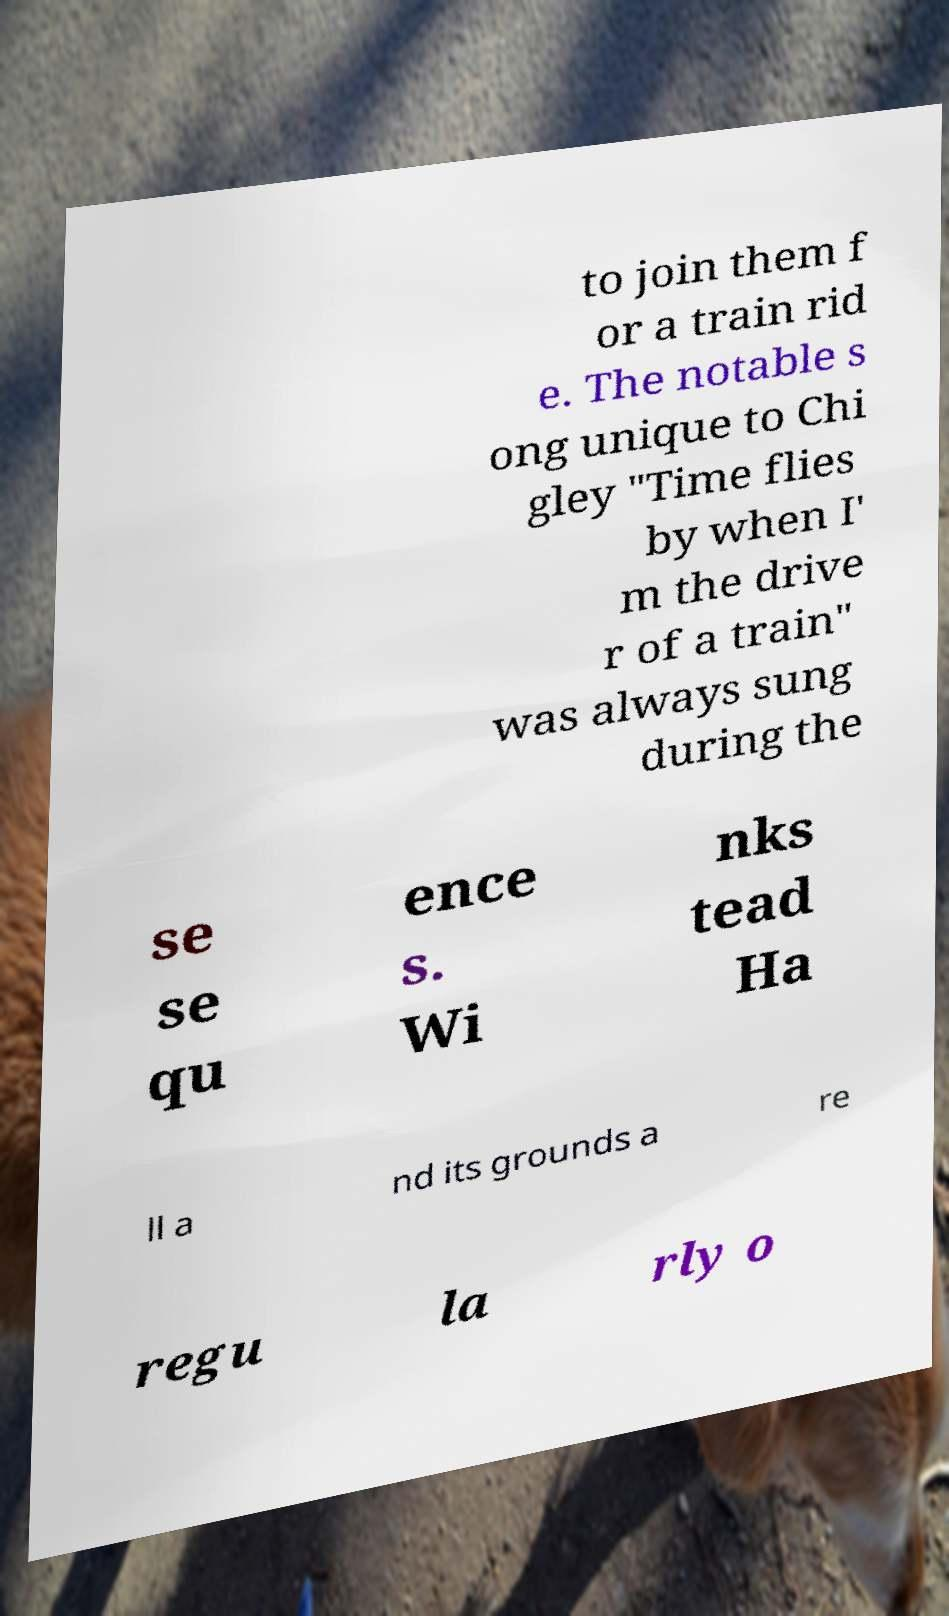Please identify and transcribe the text found in this image. to join them f or a train rid e. The notable s ong unique to Chi gley "Time flies by when I' m the drive r of a train" was always sung during the se se qu ence s. Wi nks tead Ha ll a nd its grounds a re regu la rly o 